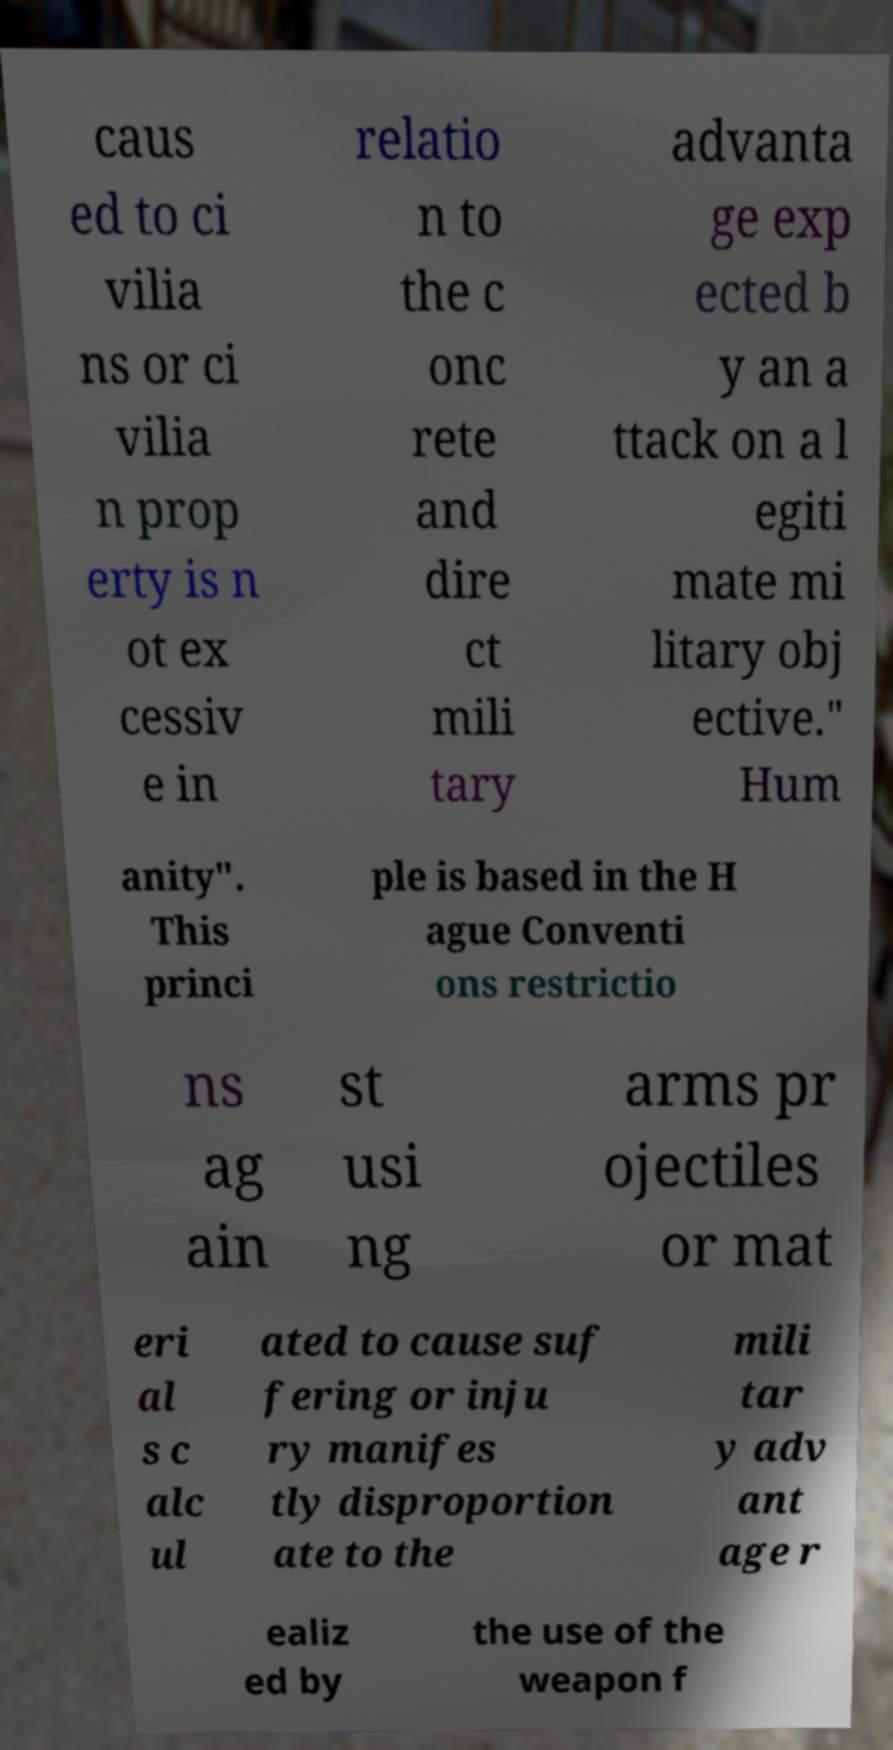I need the written content from this picture converted into text. Can you do that? caus ed to ci vilia ns or ci vilia n prop erty is n ot ex cessiv e in relatio n to the c onc rete and dire ct mili tary advanta ge exp ected b y an a ttack on a l egiti mate mi litary obj ective." Hum anity". This princi ple is based in the H ague Conventi ons restrictio ns ag ain st usi ng arms pr ojectiles or mat eri al s c alc ul ated to cause suf fering or inju ry manifes tly disproportion ate to the mili tar y adv ant age r ealiz ed by the use of the weapon f 